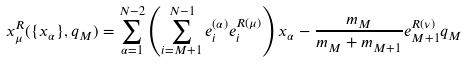Convert formula to latex. <formula><loc_0><loc_0><loc_500><loc_500>x _ { \mu } ^ { R } ( \{ x _ { \alpha } \} , q _ { M } ) = \sum _ { \alpha = 1 } ^ { N - 2 } \left ( \sum _ { i = M + 1 } ^ { N - 1 } e _ { i } ^ { ( \alpha ) } e ^ { R ( \mu ) } _ { i } \right ) x _ { \alpha } - \frac { m _ { M } } { m _ { M } + m _ { M + 1 } } e ^ { R ( \nu ) } _ { M + 1 } q _ { M }</formula> 